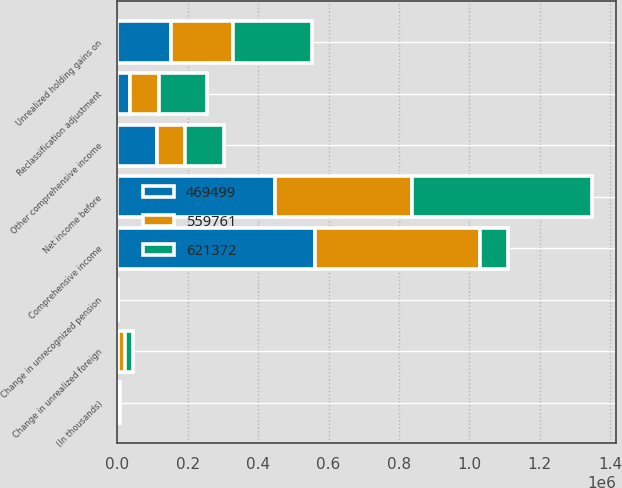<chart> <loc_0><loc_0><loc_500><loc_500><stacked_bar_chart><ecel><fcel>(In thousands)<fcel>Net income before<fcel>Change in unrealized foreign<fcel>Unrealized holding gains on<fcel>Reclassification adjustment<fcel>Change in unrecognized pension<fcel>Other comprehensive income<fcel>Comprehensive income<nl><fcel>621372<fcel>2012<fcel>510643<fcel>24563<fcel>224118<fcel>136802<fcel>1022<fcel>110857<fcel>81647<nl><fcel>559761<fcel>2011<fcel>391141<fcel>18751<fcel>177264<fcel>81647<fcel>1367<fcel>78233<fcel>469374<nl><fcel>469499<fcel>2010<fcel>446684<fcel>2117<fcel>152235<fcel>36874<fcel>120<fcel>113364<fcel>560048<nl></chart> 